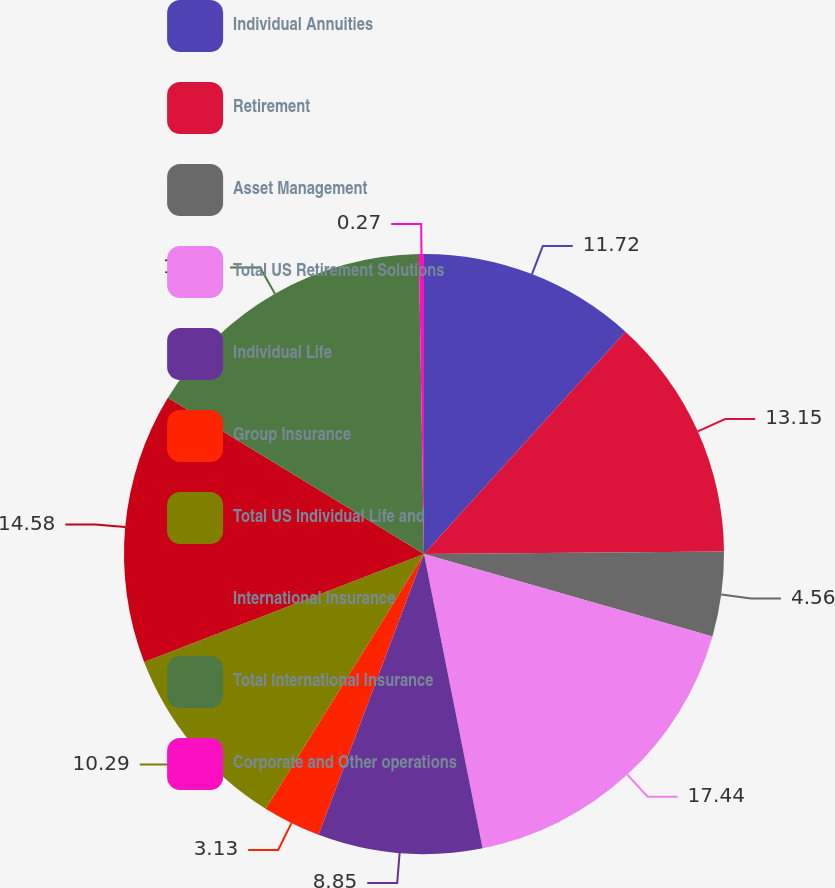Convert chart. <chart><loc_0><loc_0><loc_500><loc_500><pie_chart><fcel>Individual Annuities<fcel>Retirement<fcel>Asset Management<fcel>Total US Retirement Solutions<fcel>Individual Life<fcel>Group Insurance<fcel>Total US Individual Life and<fcel>International Insurance<fcel>Total International Insurance<fcel>Corporate and Other operations<nl><fcel>11.72%<fcel>13.15%<fcel>4.56%<fcel>17.44%<fcel>8.85%<fcel>3.13%<fcel>10.29%<fcel>14.58%<fcel>16.01%<fcel>0.27%<nl></chart> 